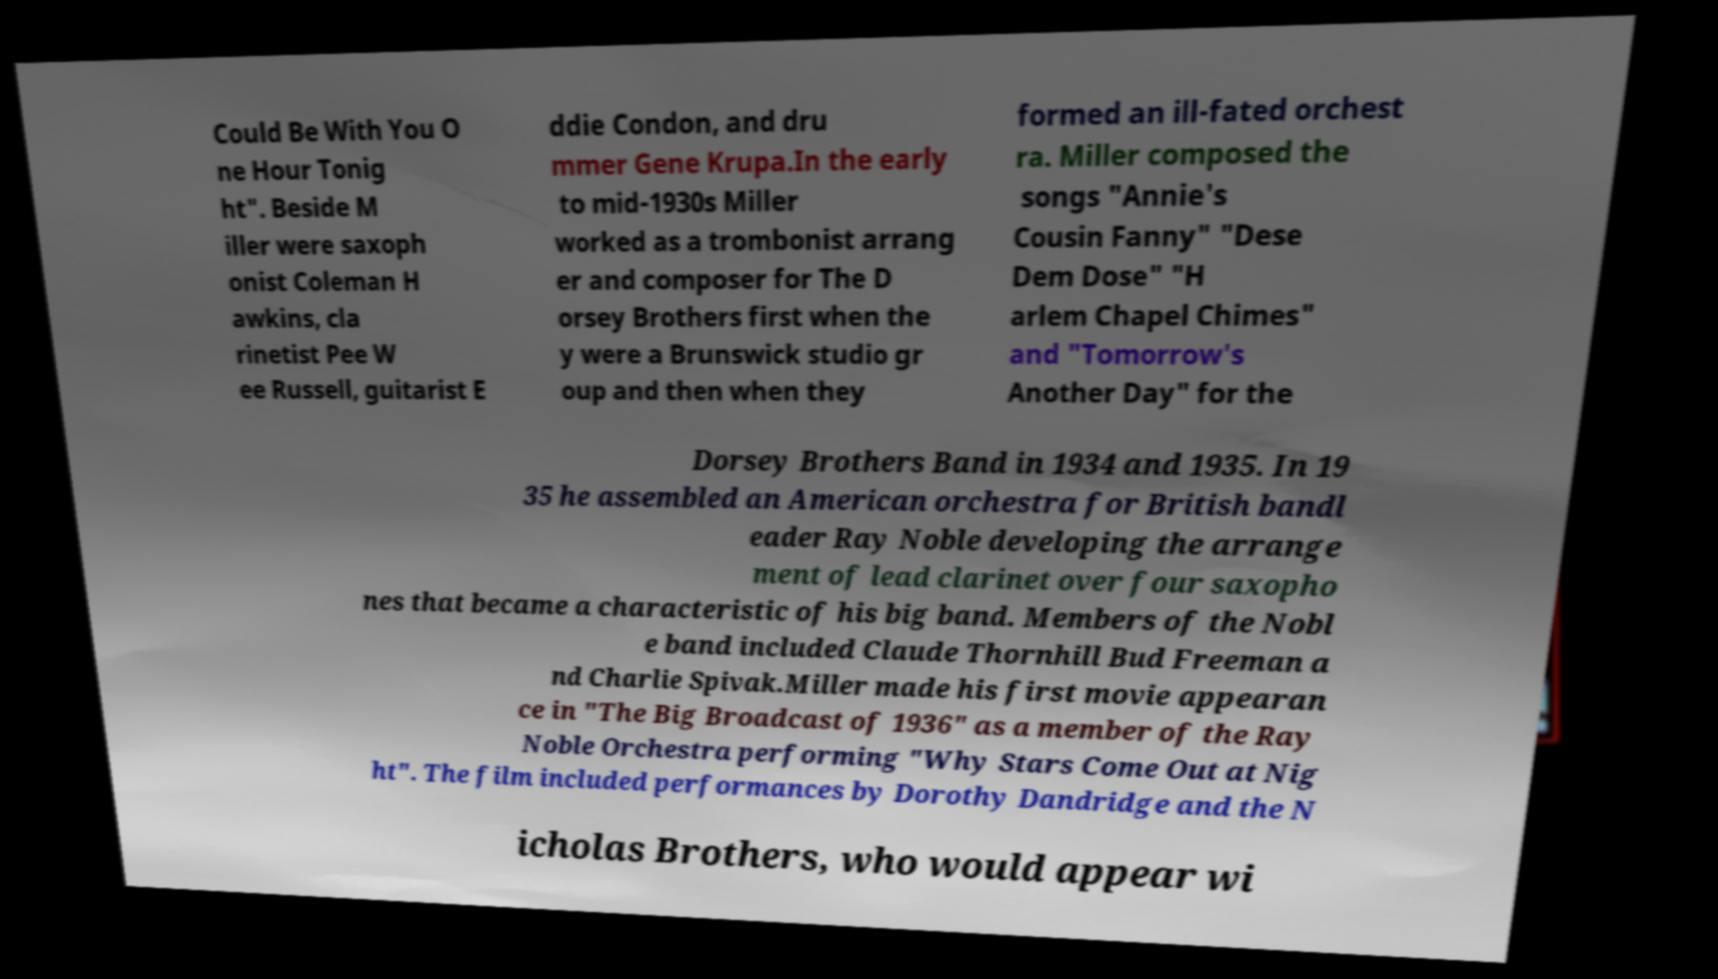There's text embedded in this image that I need extracted. Can you transcribe it verbatim? Could Be With You O ne Hour Tonig ht". Beside M iller were saxoph onist Coleman H awkins, cla rinetist Pee W ee Russell, guitarist E ddie Condon, and dru mmer Gene Krupa.In the early to mid-1930s Miller worked as a trombonist arrang er and composer for The D orsey Brothers first when the y were a Brunswick studio gr oup and then when they formed an ill-fated orchest ra. Miller composed the songs "Annie's Cousin Fanny" "Dese Dem Dose" "H arlem Chapel Chimes" and "Tomorrow's Another Day" for the Dorsey Brothers Band in 1934 and 1935. In 19 35 he assembled an American orchestra for British bandl eader Ray Noble developing the arrange ment of lead clarinet over four saxopho nes that became a characteristic of his big band. Members of the Nobl e band included Claude Thornhill Bud Freeman a nd Charlie Spivak.Miller made his first movie appearan ce in "The Big Broadcast of 1936" as a member of the Ray Noble Orchestra performing "Why Stars Come Out at Nig ht". The film included performances by Dorothy Dandridge and the N icholas Brothers, who would appear wi 